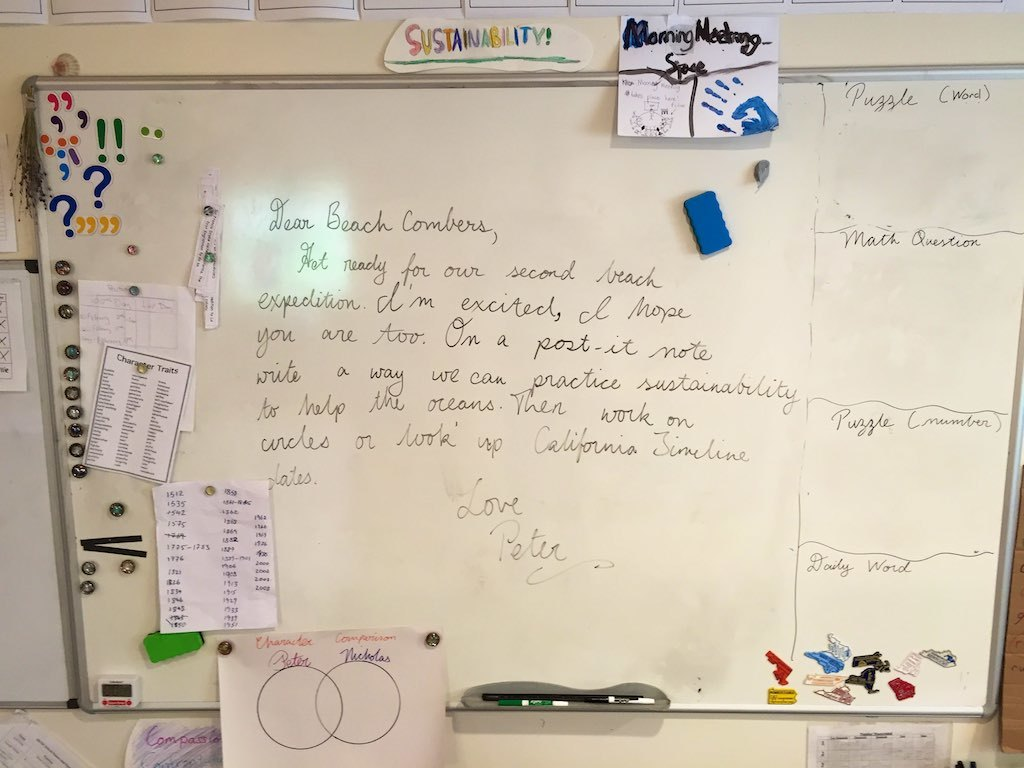What do you see happening in this image? This image features a whiteboard used for communication among coworkers. The main focal point is a note from Petra, addressed to her coworkers in Long Beach, expressing excitement for an upcoming beach expedition intended to mix leisure with sustainability efforts, such as practicing sustainability in more sustainable circles or perhaps initiating larger projects along the California shoreline. The board also displays various everyday office items like magnets, markers, and a key, suggesting a shared space for information exchange. On the right side, there are separate sections labeled 'Morning Message' and questions related to math and puzzles, hinting at a culture of daily engagement and team activities. This setup not only indicates a planning space but also reflects a collaborative and environmentally conscious team ethos. 